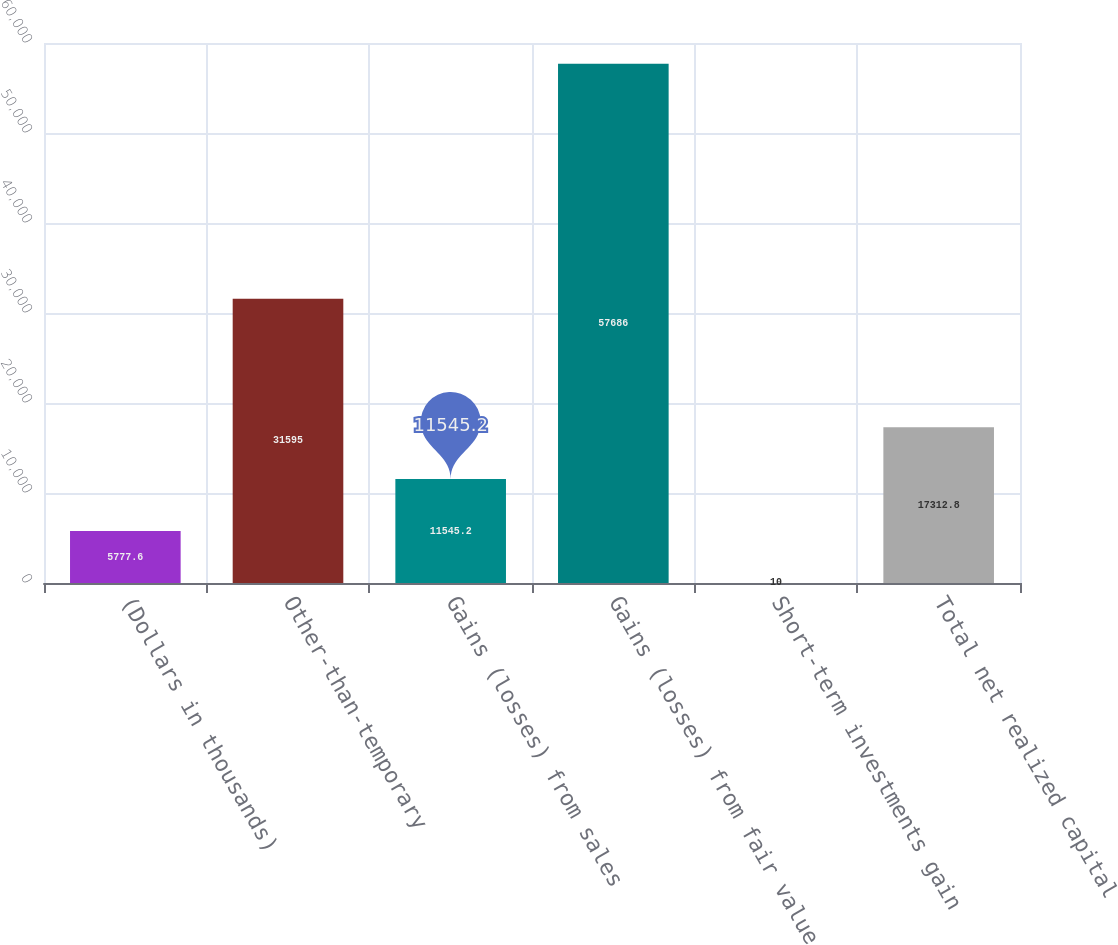Convert chart to OTSL. <chart><loc_0><loc_0><loc_500><loc_500><bar_chart><fcel>(Dollars in thousands)<fcel>Other-than-temporary<fcel>Gains (losses) from sales<fcel>Gains (losses) from fair value<fcel>Short-term investments gain<fcel>Total net realized capital<nl><fcel>5777.6<fcel>31595<fcel>11545.2<fcel>57686<fcel>10<fcel>17312.8<nl></chart> 